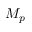Convert formula to latex. <formula><loc_0><loc_0><loc_500><loc_500>M _ { p }</formula> 